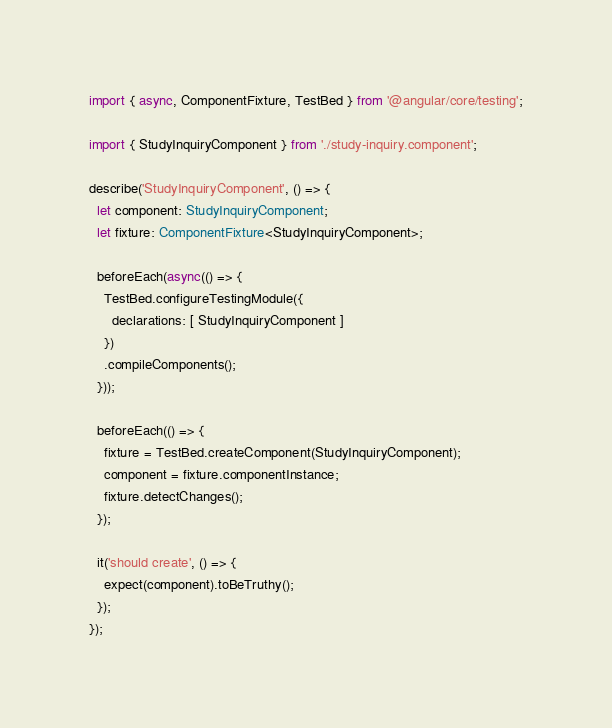Convert code to text. <code><loc_0><loc_0><loc_500><loc_500><_TypeScript_>import { async, ComponentFixture, TestBed } from '@angular/core/testing';

import { StudyInquiryComponent } from './study-inquiry.component';

describe('StudyInquiryComponent', () => {
  let component: StudyInquiryComponent;
  let fixture: ComponentFixture<StudyInquiryComponent>;

  beforeEach(async(() => {
    TestBed.configureTestingModule({
      declarations: [ StudyInquiryComponent ]
    })
    .compileComponents();
  }));

  beforeEach(() => {
    fixture = TestBed.createComponent(StudyInquiryComponent);
    component = fixture.componentInstance;
    fixture.detectChanges();
  });

  it('should create', () => {
    expect(component).toBeTruthy();
  });
});
</code> 